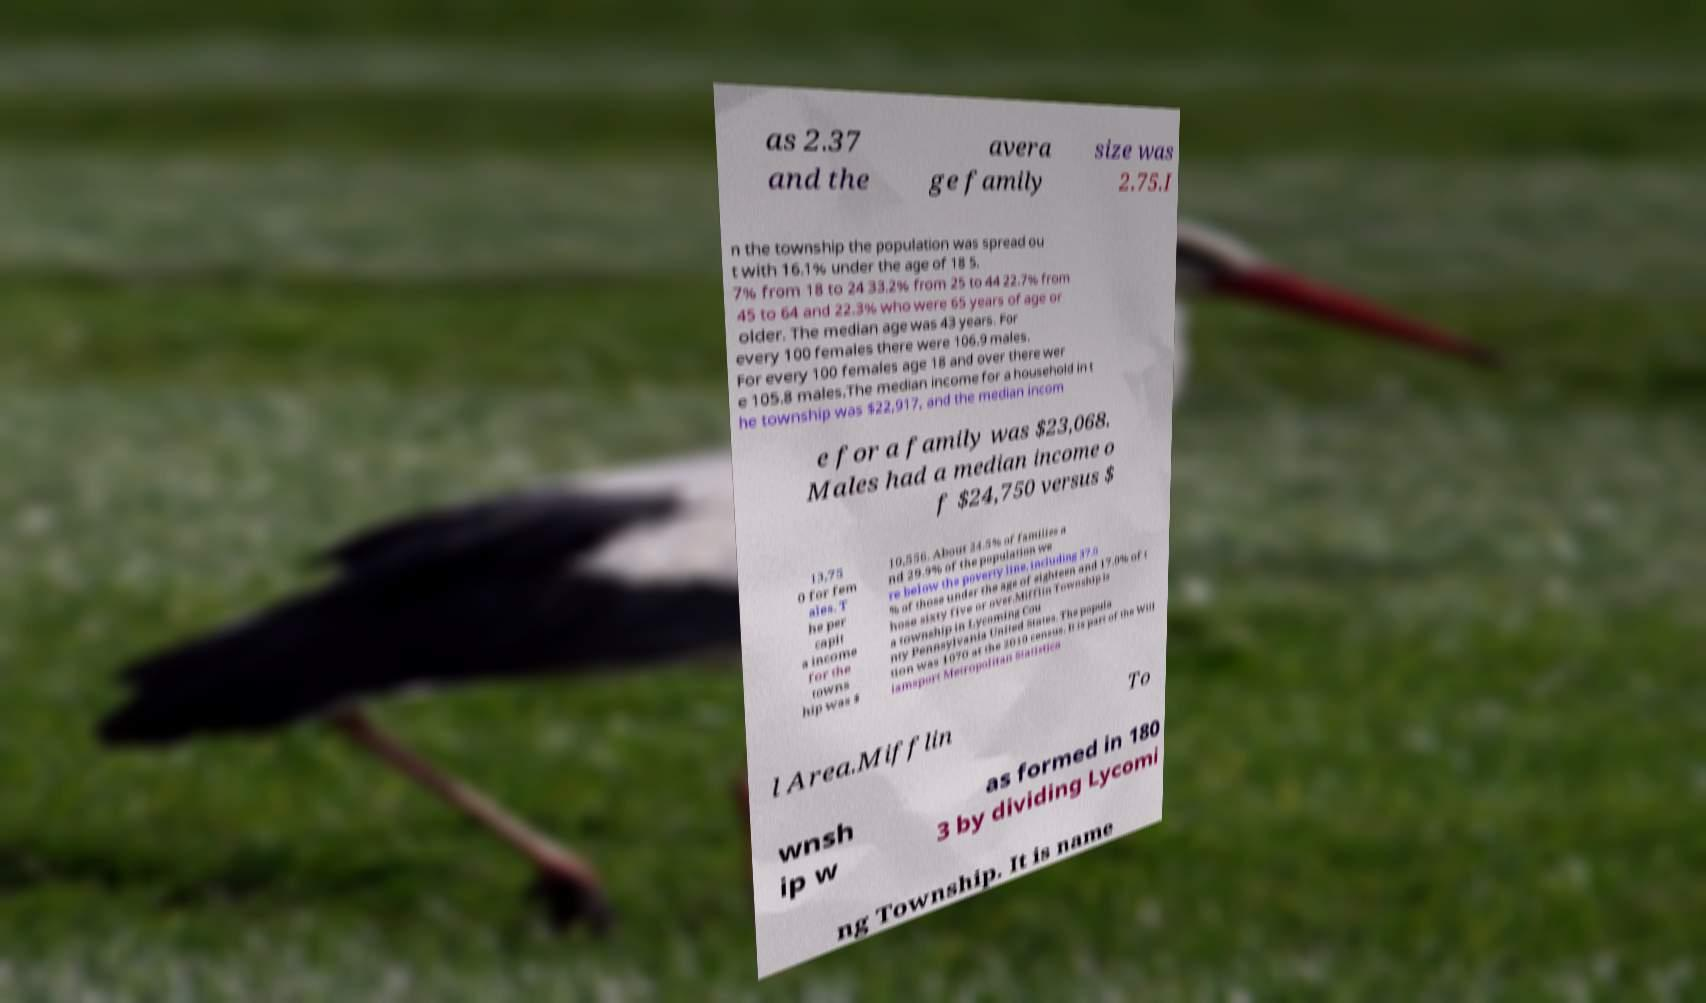There's text embedded in this image that I need extracted. Can you transcribe it verbatim? as 2.37 and the avera ge family size was 2.75.I n the township the population was spread ou t with 16.1% under the age of 18 5. 7% from 18 to 24 33.2% from 25 to 44 22.7% from 45 to 64 and 22.3% who were 65 years of age or older. The median age was 43 years. For every 100 females there were 106.9 males. For every 100 females age 18 and over there wer e 105.8 males.The median income for a household in t he township was $22,917, and the median incom e for a family was $23,068. Males had a median income o f $24,750 versus $ 13,75 0 for fem ales. T he per capit a income for the towns hip was $ 10,556. About 24.5% of families a nd 29.9% of the population we re below the poverty line, including 37.0 % of those under the age of eighteen and 17.0% of t hose sixty five or over.Mifflin Township is a township in Lycoming Cou nty Pennsylvania United States. The popula tion was 1070 at the 2010 census. It is part of the Will iamsport Metropolitan Statistica l Area.Mifflin To wnsh ip w as formed in 180 3 by dividing Lycomi ng Township. It is name 